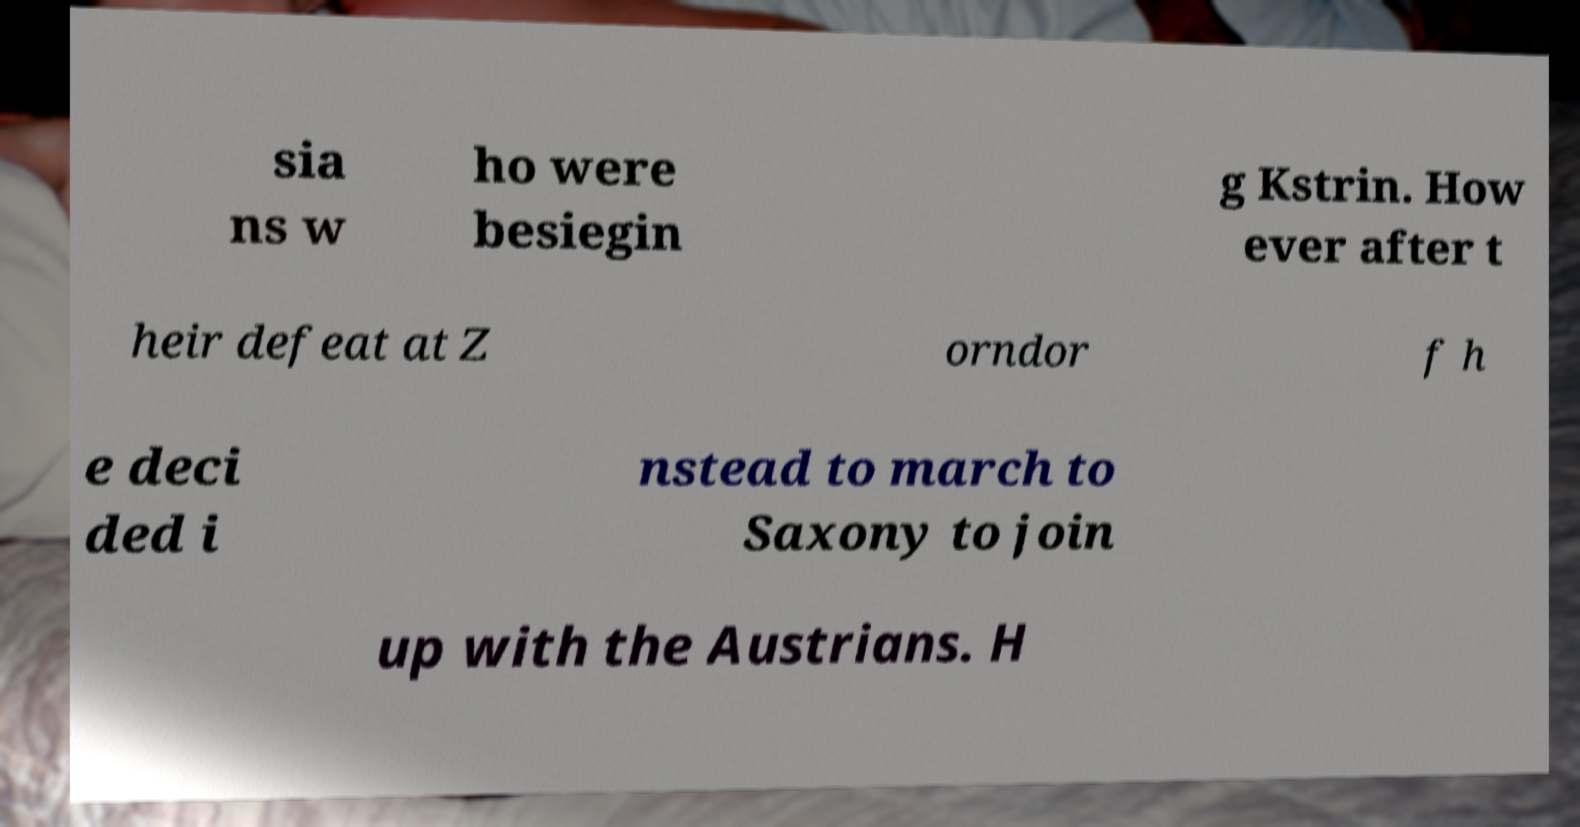I need the written content from this picture converted into text. Can you do that? sia ns w ho were besiegin g Kstrin. How ever after t heir defeat at Z orndor f h e deci ded i nstead to march to Saxony to join up with the Austrians. H 